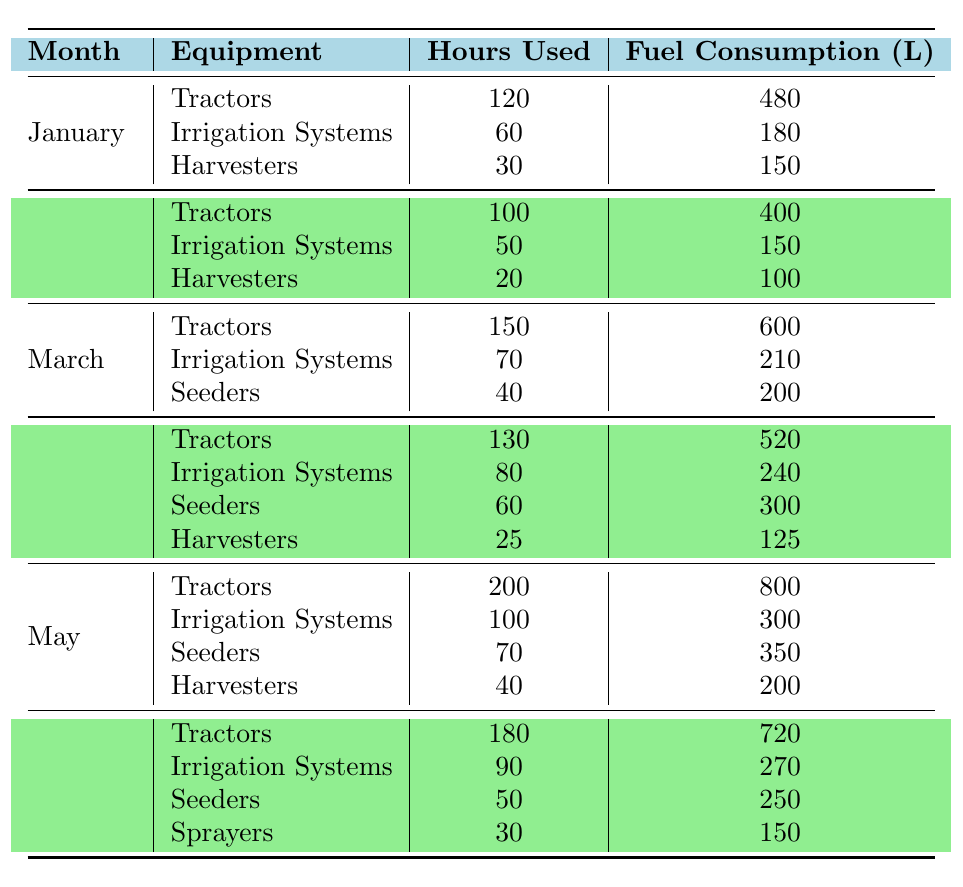What is the total fuel consumption for tractors in January? The table shows that tractors used 120 hours in January, resulting in a fuel consumption of 480 liters. Therefore, the total fuel consumption for tractors in January is 480 liters.
Answer: 480 liters How many hours were irrigation systems used in April? From the table, irrigation systems were used for 80 hours in April.
Answer: 80 hours Which month had the highest fuel consumption from seeders? The table indicates that seeders were used for 60 hours in April with a fuel consumption of 300 liters, and 70 hours in May with a fuel consumption of 350 liters. This means May had the highest fuel consumption for seeders at 350 liters.
Answer: May (350 liters) Is the total fuel consumption for irrigation systems greater than for harvesters in March? Irrigation systems in March consumed 210 liters, while harvesters consumed 200 liters. Since 210 is greater than 200, the total fuel consumption for irrigation systems is indeed greater than that for harvesters in March.
Answer: Yes What is the average fuel consumption per hour for tractors from January to June? The total fuel consumption for tractors is the sum of their consumption from January (480), February (400), March (600), April (520), May (800), and June (720), totaling 3520 liters. The total hours used is the sum of hours from January (120), February (100), March (150), April (130), May (200), and June (180), totaling 980 hours. The average fuel consumption per hour is then calculated as 3520 liters / 980 hours, which is approximately 3.59 liters/hour.
Answer: 3.59 liters/hour 